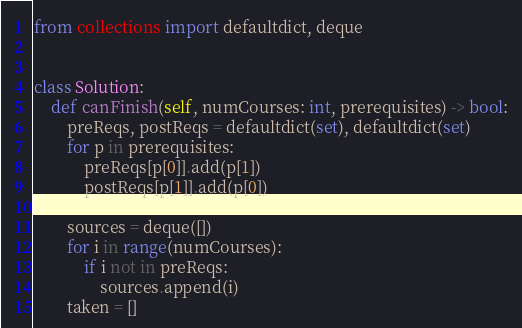<code> <loc_0><loc_0><loc_500><loc_500><_Python_>from collections import defaultdict, deque


class Solution:
    def canFinish(self, numCourses: int, prerequisites) -> bool:
        preReqs, postReqs = defaultdict(set), defaultdict(set)
        for p in prerequisites:
            preReqs[p[0]].add(p[1])
            postReqs[p[1]].add(p[0])

        sources = deque([])
        for i in range(numCourses):
            if i not in preReqs:
                sources.append(i)
        taken = []</code> 